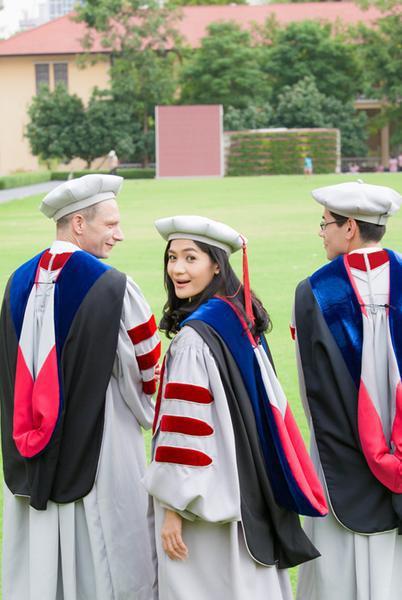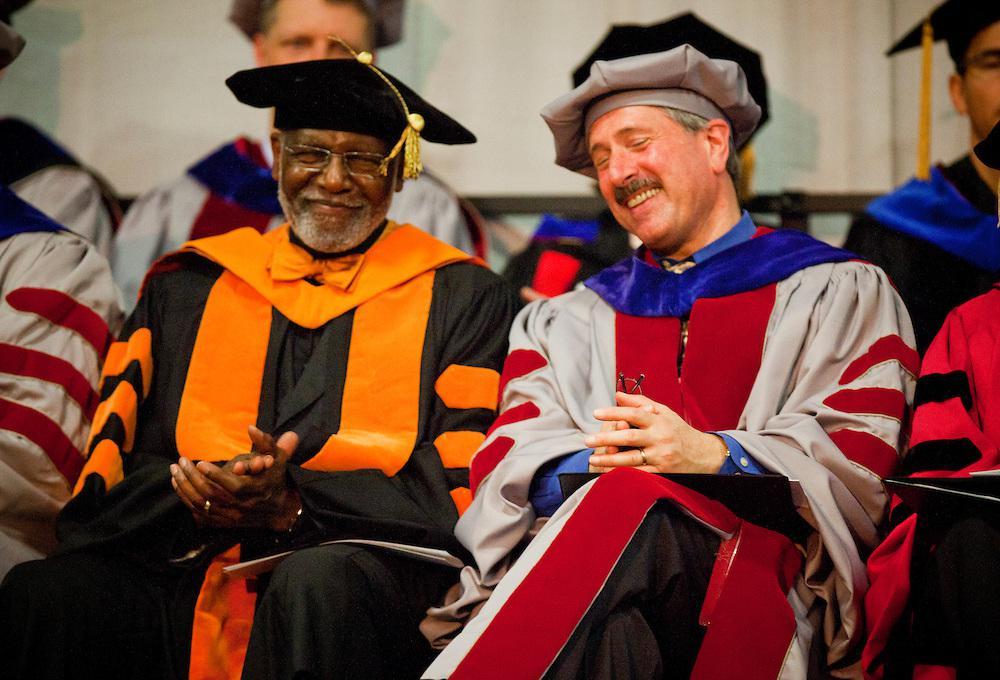The first image is the image on the left, the second image is the image on the right. Examine the images to the left and right. Is the description "An image includes in the foreground a black bearded man in a black robe and tasseled square cap near a white man in a gray robe and beret-type hat." accurate? Answer yes or no. Yes. The first image is the image on the left, the second image is the image on the right. Given the left and right images, does the statement "The left image contains no more than three graduation students." hold true? Answer yes or no. Yes. 